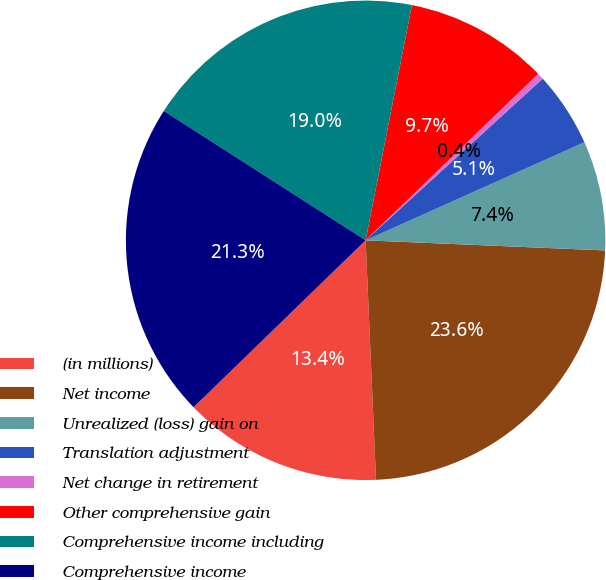Convert chart to OTSL. <chart><loc_0><loc_0><loc_500><loc_500><pie_chart><fcel>(in millions)<fcel>Net income<fcel>Unrealized (loss) gain on<fcel>Translation adjustment<fcel>Net change in retirement<fcel>Other comprehensive gain<fcel>Comprehensive income including<fcel>Comprehensive income<nl><fcel>13.43%<fcel>23.64%<fcel>7.38%<fcel>5.07%<fcel>0.44%<fcel>9.69%<fcel>19.02%<fcel>21.33%<nl></chart> 